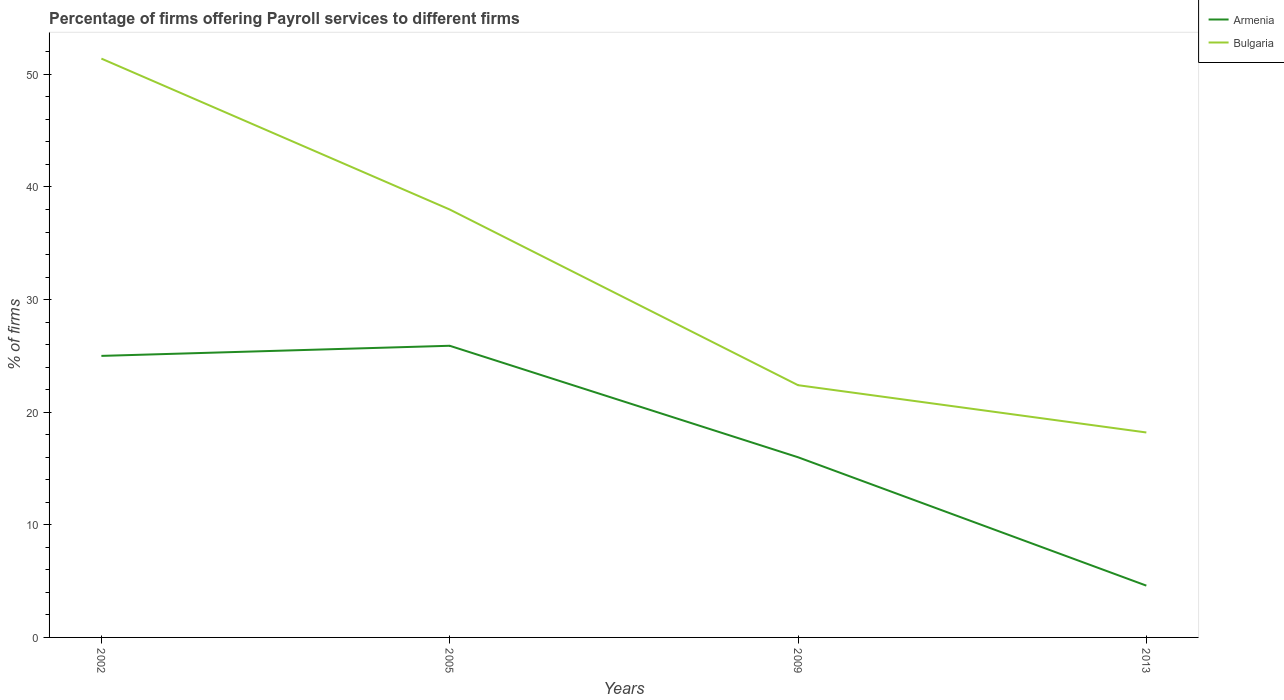How many different coloured lines are there?
Ensure brevity in your answer.  2. In which year was the percentage of firms offering payroll services in Bulgaria maximum?
Your response must be concise. 2013. What is the total percentage of firms offering payroll services in Armenia in the graph?
Your answer should be very brief. 20.4. What is the difference between the highest and the second highest percentage of firms offering payroll services in Bulgaria?
Provide a short and direct response. 33.2. What is the difference between the highest and the lowest percentage of firms offering payroll services in Bulgaria?
Keep it short and to the point. 2. Is the percentage of firms offering payroll services in Bulgaria strictly greater than the percentage of firms offering payroll services in Armenia over the years?
Your response must be concise. No. How many years are there in the graph?
Your answer should be compact. 4. What is the difference between two consecutive major ticks on the Y-axis?
Your response must be concise. 10. Are the values on the major ticks of Y-axis written in scientific E-notation?
Give a very brief answer. No. What is the title of the graph?
Offer a terse response. Percentage of firms offering Payroll services to different firms. Does "Ecuador" appear as one of the legend labels in the graph?
Provide a succinct answer. No. What is the label or title of the X-axis?
Your response must be concise. Years. What is the label or title of the Y-axis?
Make the answer very short. % of firms. What is the % of firms of Bulgaria in 2002?
Your answer should be compact. 51.4. What is the % of firms of Armenia in 2005?
Keep it short and to the point. 25.9. What is the % of firms of Bulgaria in 2009?
Offer a terse response. 22.4. Across all years, what is the maximum % of firms in Armenia?
Provide a short and direct response. 25.9. Across all years, what is the maximum % of firms of Bulgaria?
Offer a very short reply. 51.4. Across all years, what is the minimum % of firms in Armenia?
Your answer should be very brief. 4.6. What is the total % of firms in Armenia in the graph?
Make the answer very short. 71.5. What is the total % of firms in Bulgaria in the graph?
Offer a very short reply. 130. What is the difference between the % of firms in Bulgaria in 2002 and that in 2005?
Your response must be concise. 13.4. What is the difference between the % of firms of Armenia in 2002 and that in 2013?
Provide a short and direct response. 20.4. What is the difference between the % of firms of Bulgaria in 2002 and that in 2013?
Keep it short and to the point. 33.2. What is the difference between the % of firms in Armenia in 2005 and that in 2009?
Make the answer very short. 9.9. What is the difference between the % of firms of Bulgaria in 2005 and that in 2009?
Give a very brief answer. 15.6. What is the difference between the % of firms in Armenia in 2005 and that in 2013?
Provide a short and direct response. 21.3. What is the difference between the % of firms of Bulgaria in 2005 and that in 2013?
Keep it short and to the point. 19.8. What is the difference between the % of firms of Armenia in 2009 and that in 2013?
Keep it short and to the point. 11.4. What is the difference between the % of firms of Armenia in 2002 and the % of firms of Bulgaria in 2005?
Ensure brevity in your answer.  -13. What is the difference between the % of firms in Armenia in 2005 and the % of firms in Bulgaria in 2009?
Offer a terse response. 3.5. What is the difference between the % of firms of Armenia in 2005 and the % of firms of Bulgaria in 2013?
Make the answer very short. 7.7. What is the difference between the % of firms in Armenia in 2009 and the % of firms in Bulgaria in 2013?
Provide a short and direct response. -2.2. What is the average % of firms in Armenia per year?
Keep it short and to the point. 17.88. What is the average % of firms of Bulgaria per year?
Your response must be concise. 32.5. In the year 2002, what is the difference between the % of firms of Armenia and % of firms of Bulgaria?
Ensure brevity in your answer.  -26.4. In the year 2005, what is the difference between the % of firms of Armenia and % of firms of Bulgaria?
Offer a terse response. -12.1. In the year 2013, what is the difference between the % of firms in Armenia and % of firms in Bulgaria?
Keep it short and to the point. -13.6. What is the ratio of the % of firms in Armenia in 2002 to that in 2005?
Provide a succinct answer. 0.97. What is the ratio of the % of firms in Bulgaria in 2002 to that in 2005?
Ensure brevity in your answer.  1.35. What is the ratio of the % of firms in Armenia in 2002 to that in 2009?
Keep it short and to the point. 1.56. What is the ratio of the % of firms of Bulgaria in 2002 to that in 2009?
Provide a short and direct response. 2.29. What is the ratio of the % of firms of Armenia in 2002 to that in 2013?
Offer a very short reply. 5.43. What is the ratio of the % of firms in Bulgaria in 2002 to that in 2013?
Offer a terse response. 2.82. What is the ratio of the % of firms in Armenia in 2005 to that in 2009?
Ensure brevity in your answer.  1.62. What is the ratio of the % of firms in Bulgaria in 2005 to that in 2009?
Make the answer very short. 1.7. What is the ratio of the % of firms in Armenia in 2005 to that in 2013?
Give a very brief answer. 5.63. What is the ratio of the % of firms in Bulgaria in 2005 to that in 2013?
Your answer should be very brief. 2.09. What is the ratio of the % of firms in Armenia in 2009 to that in 2013?
Give a very brief answer. 3.48. What is the ratio of the % of firms of Bulgaria in 2009 to that in 2013?
Offer a very short reply. 1.23. What is the difference between the highest and the lowest % of firms of Armenia?
Offer a terse response. 21.3. What is the difference between the highest and the lowest % of firms in Bulgaria?
Your response must be concise. 33.2. 